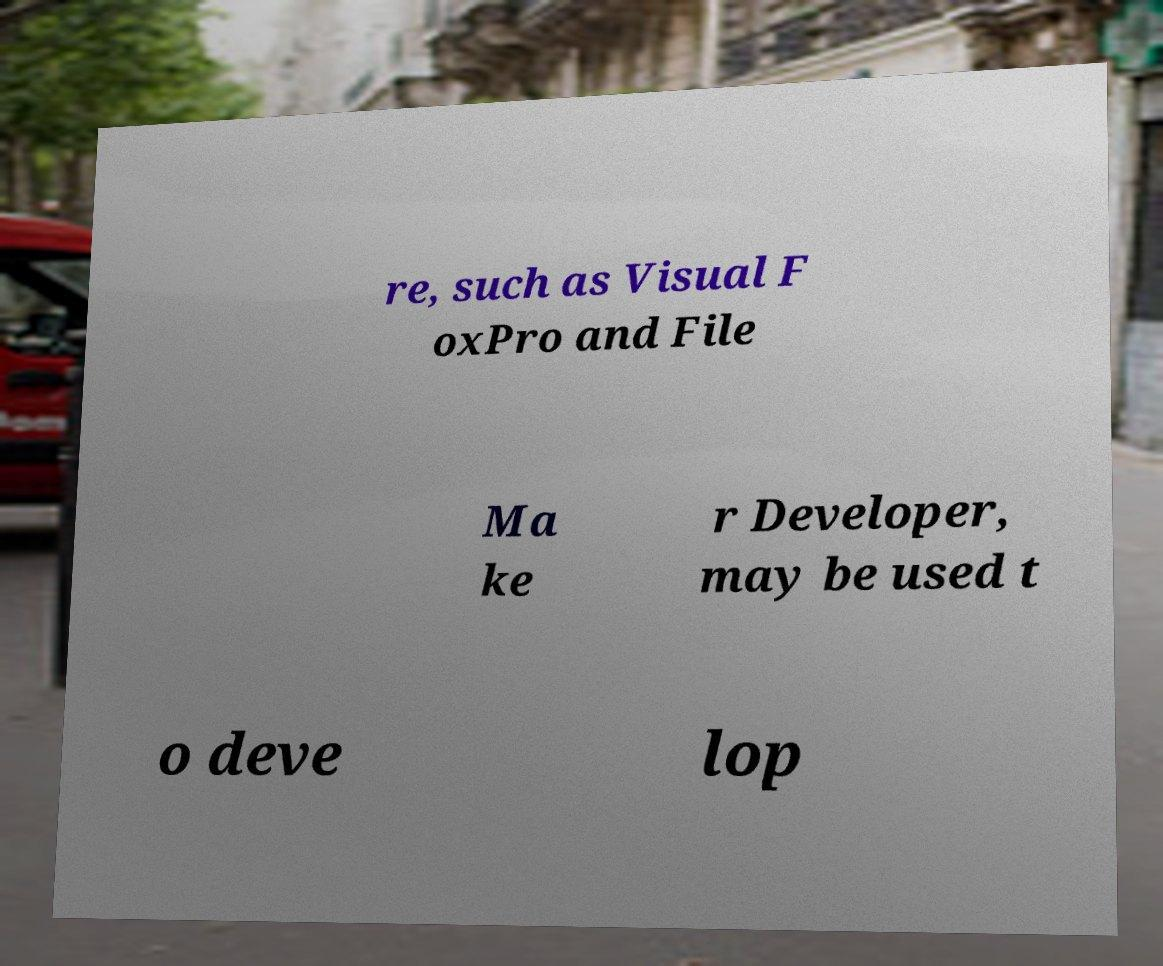What messages or text are displayed in this image? I need them in a readable, typed format. re, such as Visual F oxPro and File Ma ke r Developer, may be used t o deve lop 